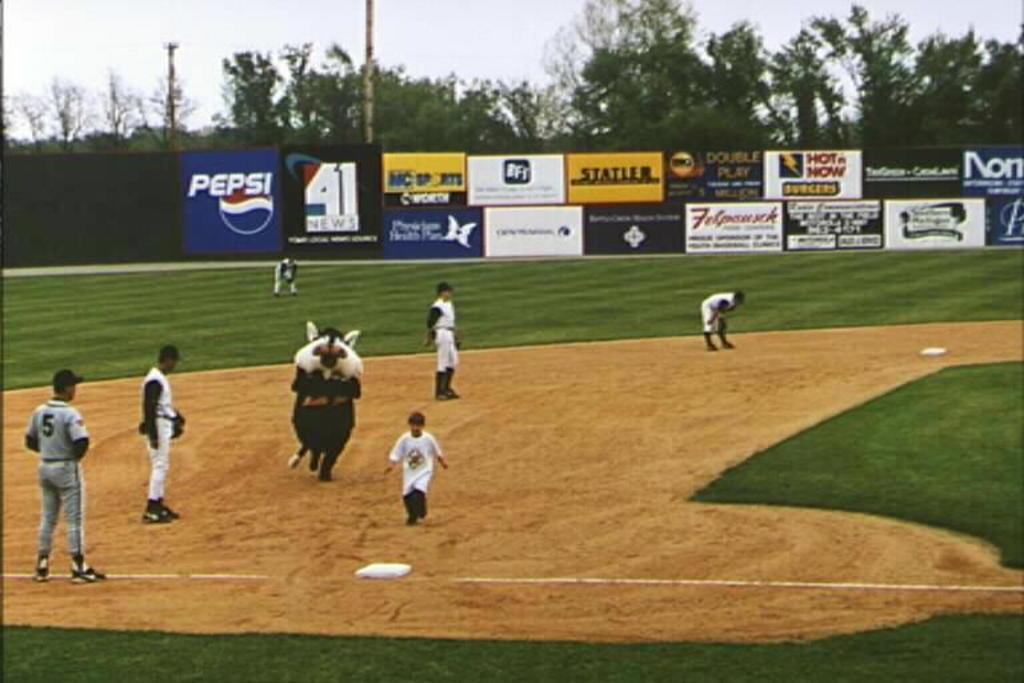Describe this image in one or two sentences. In this image we can see a group of people standing on the ground. In that a man is wearing a costume. On the backside we can see some boards with some text on it, a group of trees, poles and the sky which looks cloudy. 